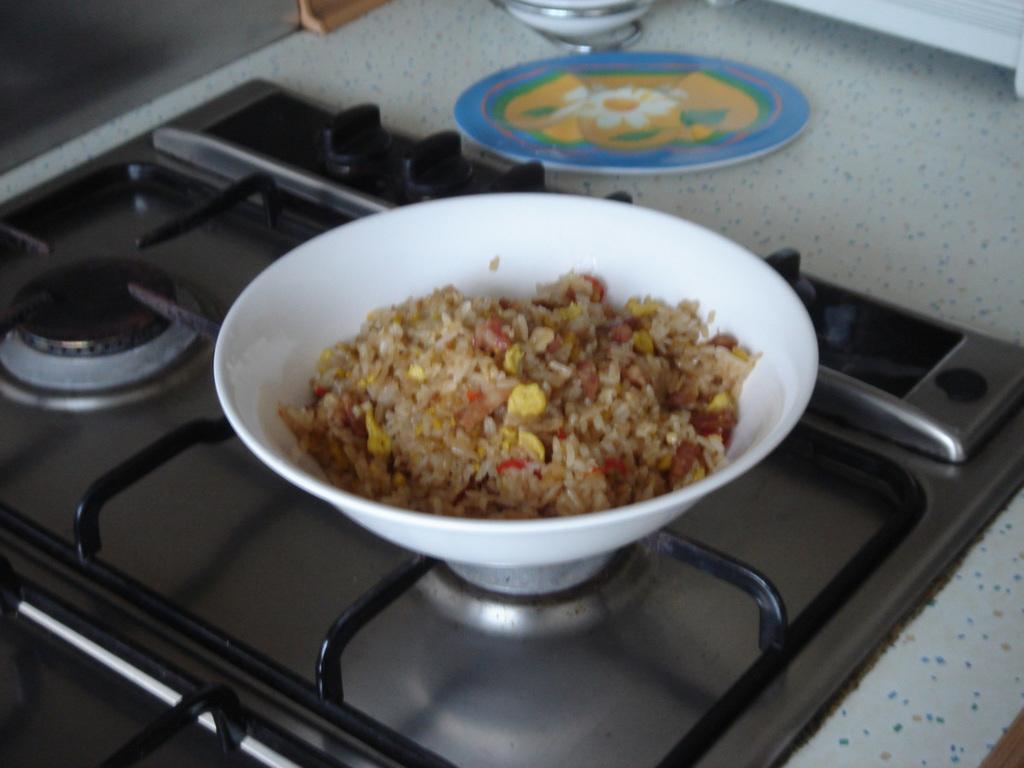Can you describe this image briefly? In this image we can see some food in a bowl which is placed on the stove. We can also see a plate beside it. 